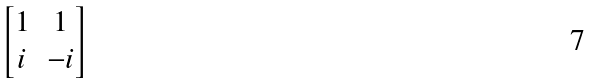Convert formula to latex. <formula><loc_0><loc_0><loc_500><loc_500>\begin{bmatrix} 1 & 1 \\ { i } & - { i } \\ \end{bmatrix}</formula> 